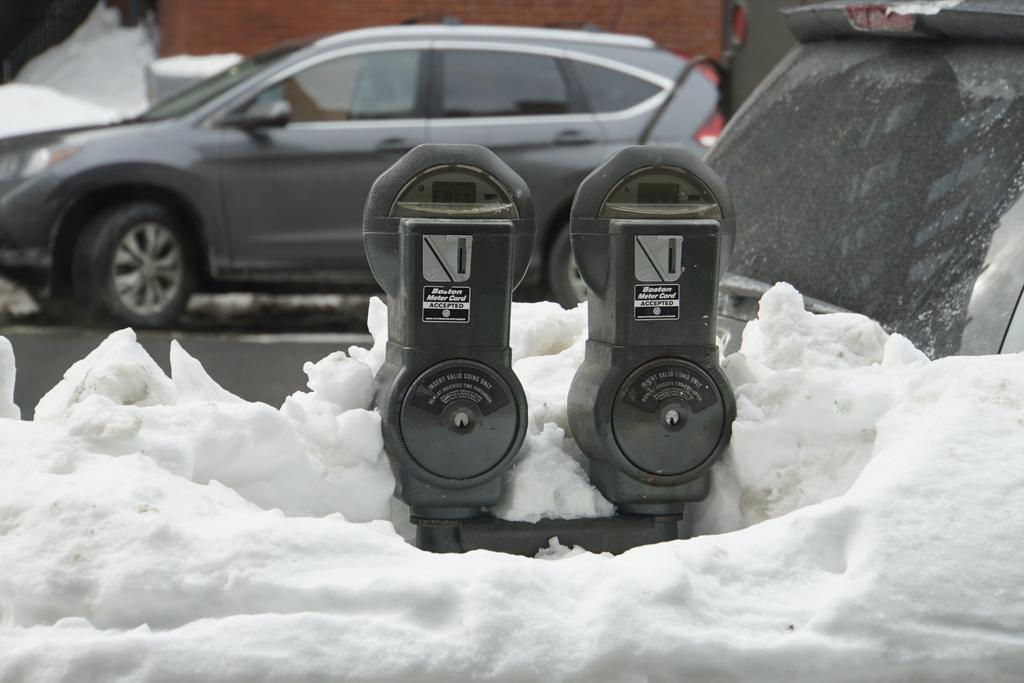<image>
Describe the image concisely. A set of Boston parking meters is almost buried in snow. 